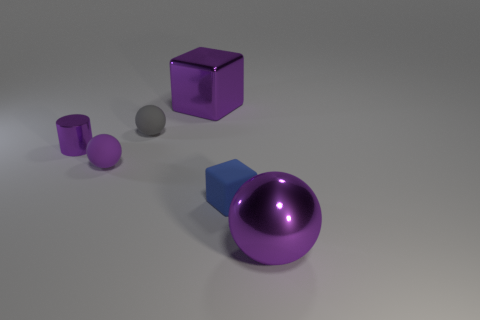Add 4 tiny gray objects. How many objects exist? 10 Subtract all cylinders. How many objects are left? 5 Subtract 0 green blocks. How many objects are left? 6 Subtract all purple cubes. Subtract all small metal things. How many objects are left? 4 Add 4 gray matte objects. How many gray matte objects are left? 5 Add 6 green matte cubes. How many green matte cubes exist? 6 